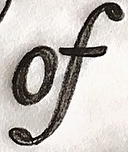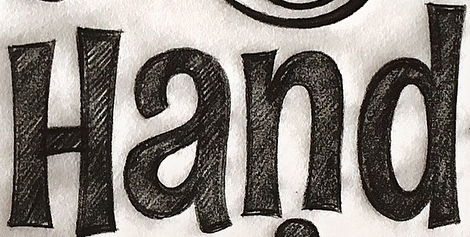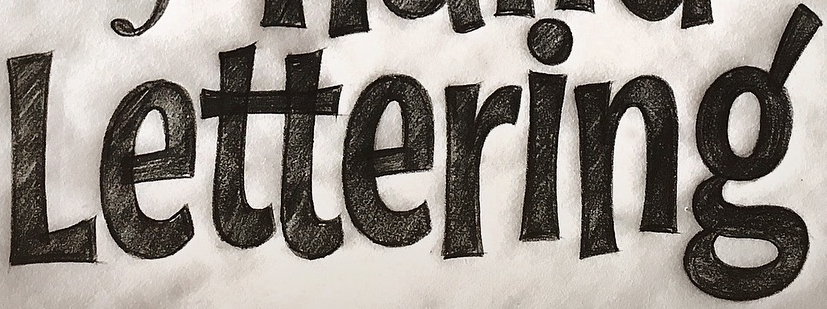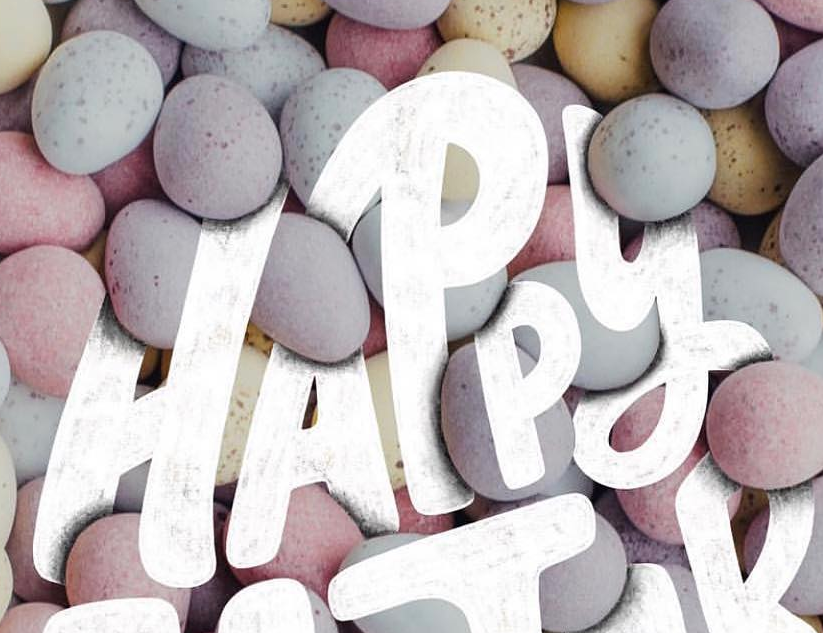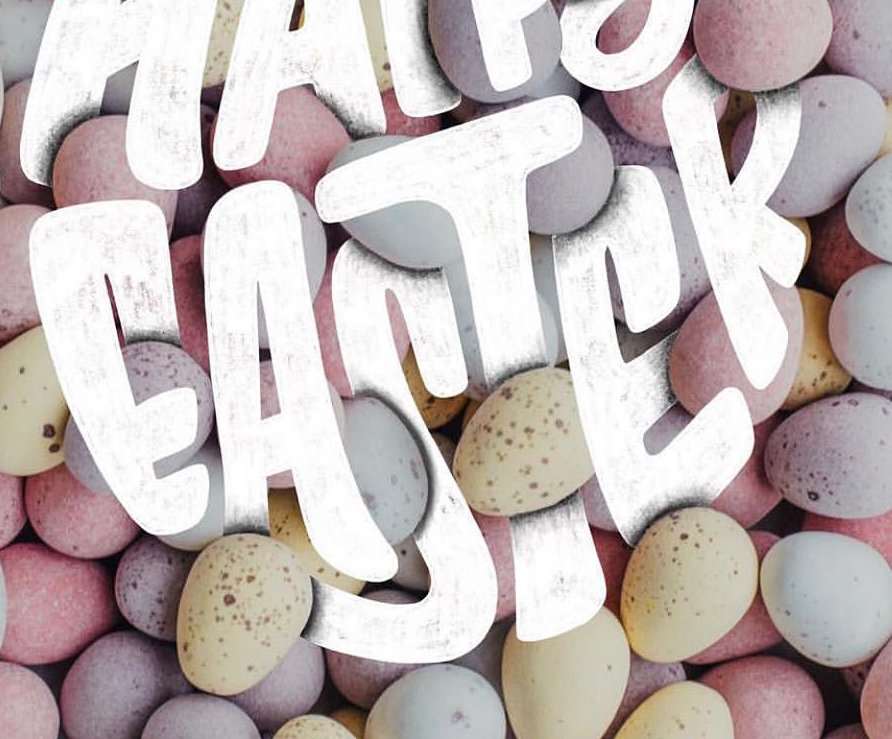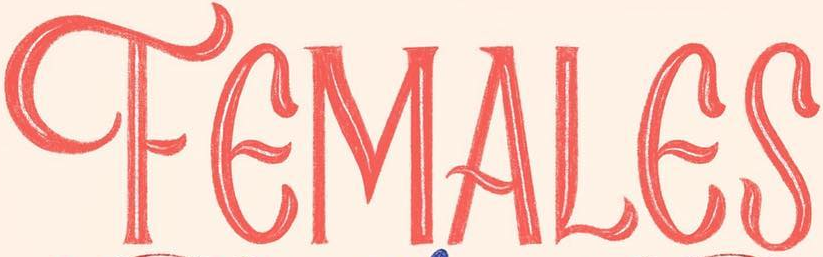What words can you see in these images in sequence, separated by a semicolon? of; Hand; Lettering; HAPPY; EASTER; FEMALES 